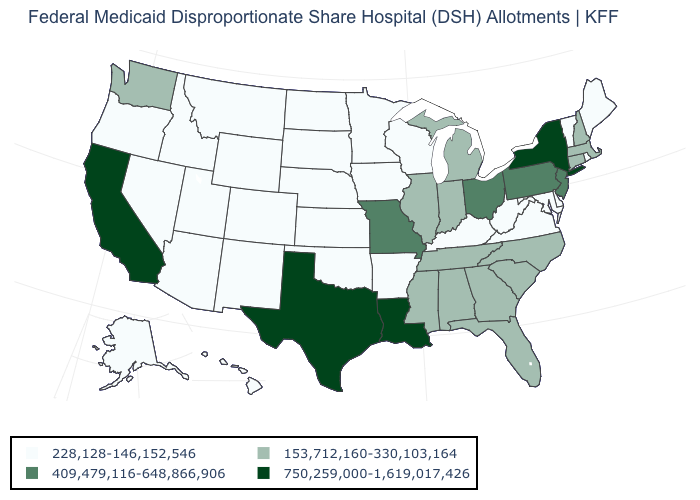Does the first symbol in the legend represent the smallest category?
Keep it brief. Yes. What is the value of Rhode Island?
Keep it brief. 228,128-146,152,546. How many symbols are there in the legend?
Answer briefly. 4. Which states have the lowest value in the West?
Give a very brief answer. Alaska, Arizona, Colorado, Hawaii, Idaho, Montana, Nevada, New Mexico, Oregon, Utah, Wyoming. What is the lowest value in the USA?
Be succinct. 228,128-146,152,546. Does Montana have the highest value in the West?
Be succinct. No. Does Georgia have the lowest value in the USA?
Quick response, please. No. Which states have the highest value in the USA?
Answer briefly. California, Louisiana, New York, Texas. What is the lowest value in states that border Montana?
Give a very brief answer. 228,128-146,152,546. What is the value of New Mexico?
Short answer required. 228,128-146,152,546. What is the highest value in the USA?
Quick response, please. 750,259,000-1,619,017,426. Does Kentucky have a lower value than Wyoming?
Concise answer only. No. Name the states that have a value in the range 750,259,000-1,619,017,426?
Short answer required. California, Louisiana, New York, Texas. Is the legend a continuous bar?
Keep it brief. No. Among the states that border Wisconsin , which have the lowest value?
Short answer required. Iowa, Minnesota. 